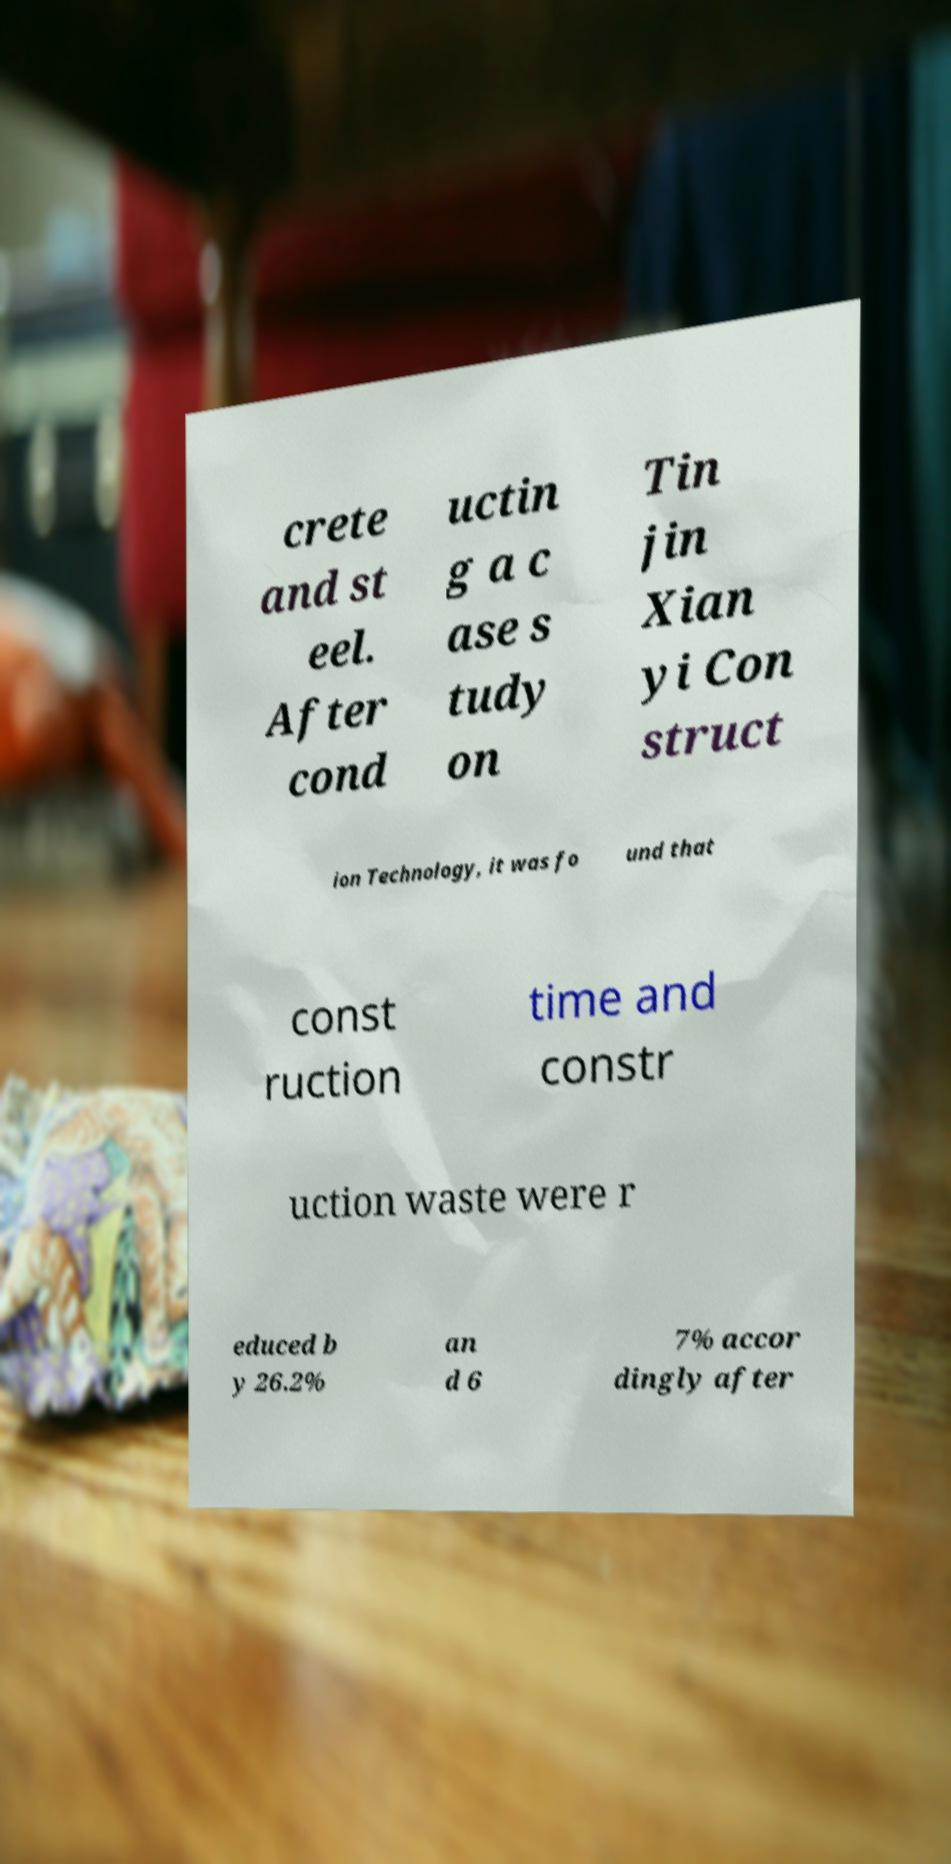For documentation purposes, I need the text within this image transcribed. Could you provide that? crete and st eel. After cond uctin g a c ase s tudy on Tin jin Xian yi Con struct ion Technology, it was fo und that const ruction time and constr uction waste were r educed b y 26.2% an d 6 7% accor dingly after 